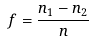Convert formula to latex. <formula><loc_0><loc_0><loc_500><loc_500>f = \frac { n _ { 1 } - n _ { 2 } } { n }</formula> 